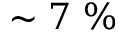Convert formula to latex. <formula><loc_0><loc_0><loc_500><loc_500>\sim 7 \%</formula> 